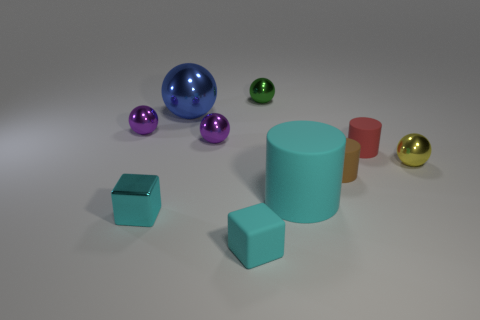Subtract all big shiny balls. How many balls are left? 4 Subtract all gray balls. Subtract all red cylinders. How many balls are left? 5 Subtract all blocks. How many objects are left? 8 Add 3 small cyan cubes. How many small cyan cubes are left? 5 Add 9 small brown metal blocks. How many small brown metal blocks exist? 9 Subtract 1 green balls. How many objects are left? 9 Subtract all red cylinders. Subtract all big cyan cylinders. How many objects are left? 8 